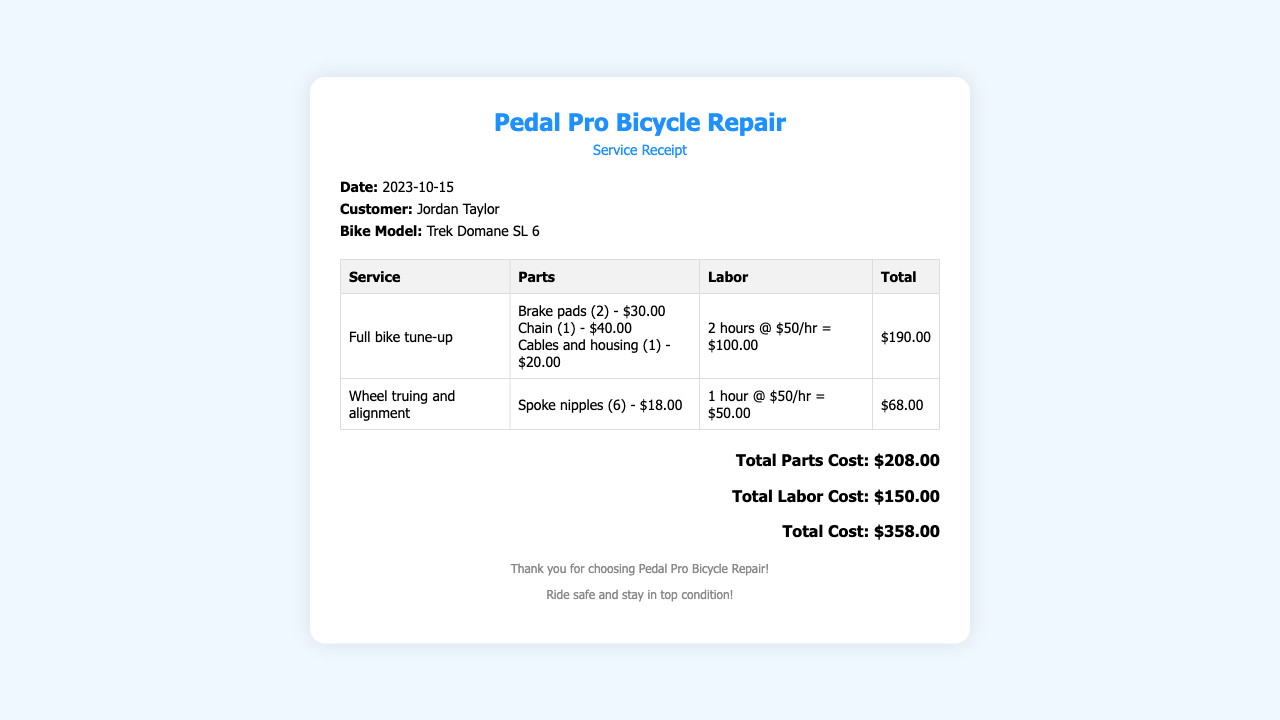what is the date of the service? The date of the service is stated in the details section of the receipt, which is 2023-10-15.
Answer: 2023-10-15 who is the customer? The customer's name is provided in the details section of the receipt, which is Jordan Taylor.
Answer: Jordan Taylor what is the bike model? The bike model is indicated in the details section, which is Trek Domane SL 6.
Answer: Trek Domane SL 6 what is the total cost? The total cost is displayed at the bottom of the receipt, which sums the services and parts, amounting to $358.
Answer: $358.00 how many hours of labor were charges for the full bike tune-up? The labor charges for the full bike tune-up is indicated as 2 hours.
Answer: 2 hours how much did the brake pads cost? The cost of the brake pads is specified in the parts section of the receipt, which is $30.00.
Answer: $30.00 what was the labor rate per hour? The labor rate per hour is mentioned in the services, which is $50/hr.
Answer: $50/hr what is the total parts cost? The total parts cost is provided in the summary section, which sums all parts used in the services, amounting to $208.
Answer: $208.00 how many spoke nipples were replaced? The number of spoke nipples replaced is detailed in the wheel truing and alignment service, which states 6 spoke nipples.
Answer: 6 